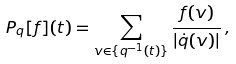<formula> <loc_0><loc_0><loc_500><loc_500>P _ { q } [ f ] ( t ) = \sum _ { v \in \{ q ^ { - 1 } ( t ) \} } \frac { f ( v ) } { \left | \dot { q } ( v ) \right | } \, ,</formula> 